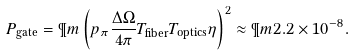<formula> <loc_0><loc_0><loc_500><loc_500>P _ { \text {gate} } = \P m \left ( p _ { \pi } \frac { \Delta \Omega } { 4 \pi } T _ { \text {fiber} } T _ { \text {optics} } \eta \right ) ^ { 2 } \approx \P m 2 . 2 \times 1 0 ^ { - 8 } .</formula> 